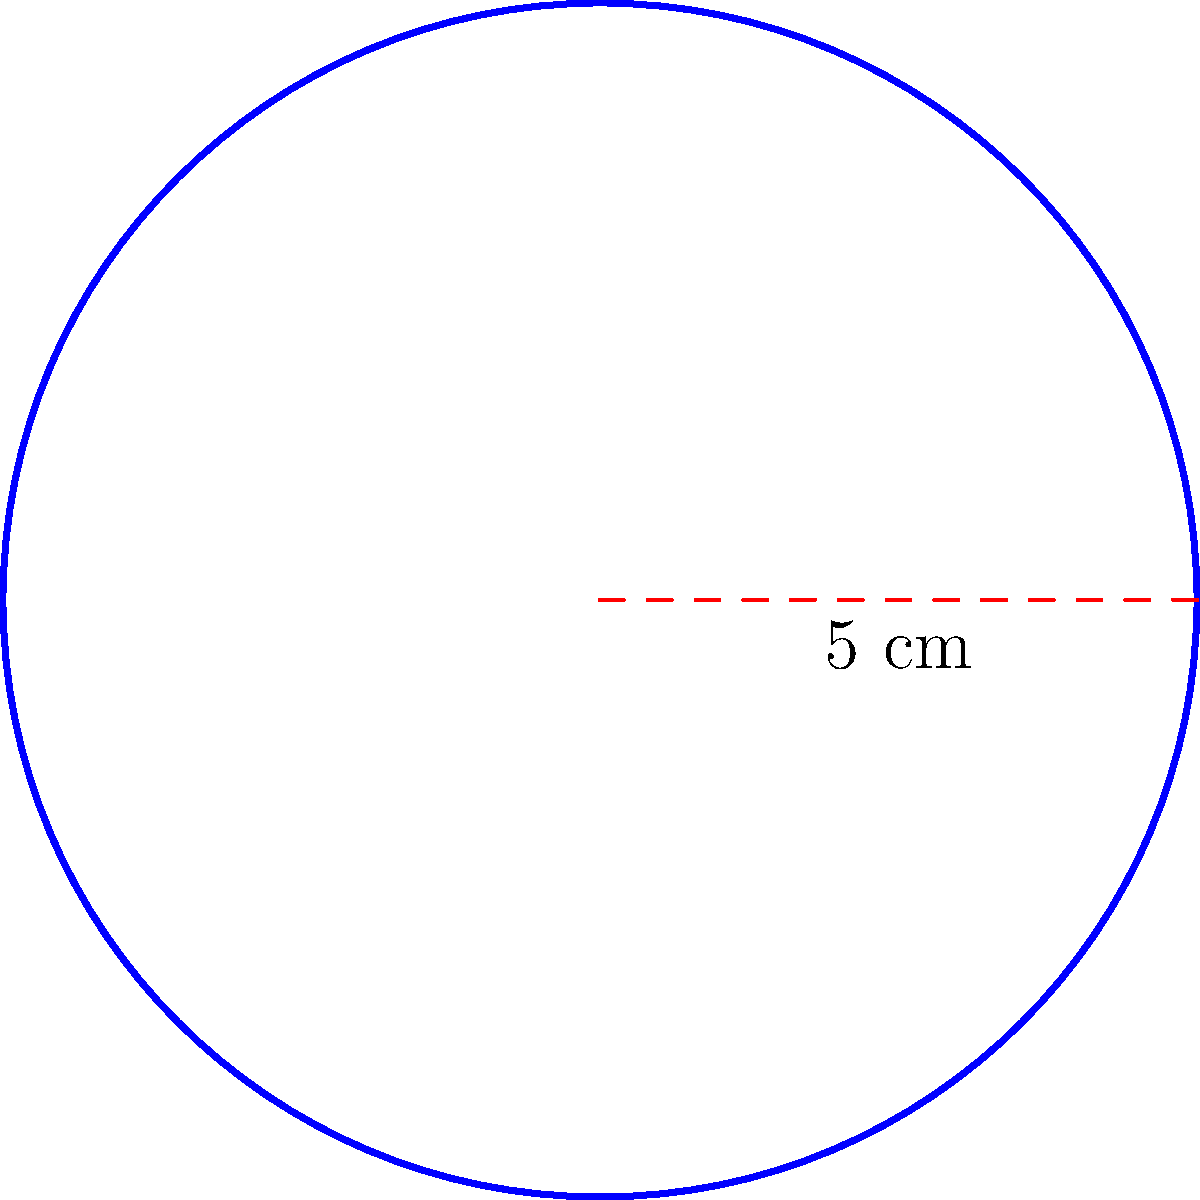You're designing a simple circular logo for your kid's soccer team jerseys. The logo's radius is 5 cm. What's the perimeter of this logo? (Use $\pi = 3.14$ for calculations) Let's break this down into simple steps:

1) The formula for the perimeter (circumference) of a circle is:
   $C = 2\pi r$, where $r$ is the radius

2) We're given that the radius is 5 cm and we should use $\pi = 3.14$

3) Let's plug these values into the formula:
   $C = 2 \times 3.14 \times 5$

4) Now, let's do the math:
   $C = 6.28 \times 5 = 31.4$ cm

5) Rounding to the nearest tenth:
   $C \approx 31.4$ cm

So, the perimeter of the circular logo is approximately 31.4 cm.
Answer: $31.4$ cm 